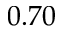Convert formula to latex. <formula><loc_0><loc_0><loc_500><loc_500>0 . 7 0</formula> 